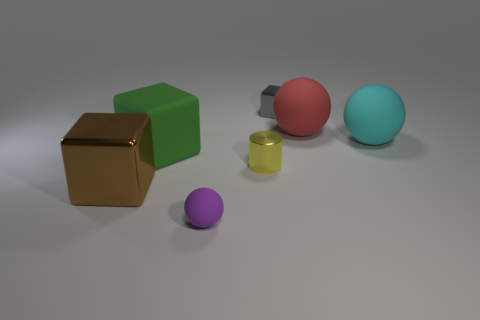Are there any other things that have the same shape as the tiny yellow thing?
Your answer should be very brief. No. There is a small yellow object; is it the same shape as the large rubber object to the left of the small gray metal cube?
Give a very brief answer. No. Are there an equal number of large metallic things behind the small ball and small cylinders behind the big green matte object?
Offer a terse response. No. What number of other things are there of the same material as the purple ball
Give a very brief answer. 3. What number of metallic things are cylinders or red things?
Your answer should be compact. 1. There is a rubber thing on the left side of the purple rubber sphere; does it have the same shape as the tiny yellow shiny object?
Your answer should be compact. No. Are there more small yellow cylinders in front of the yellow thing than big red shiny spheres?
Your answer should be very brief. No. What number of matte things are to the right of the tiny gray block and to the left of the small gray thing?
Give a very brief answer. 0. What is the color of the big matte thing in front of the big ball in front of the large red matte object?
Provide a succinct answer. Green. What number of blocks are the same color as the metallic cylinder?
Ensure brevity in your answer.  0. 